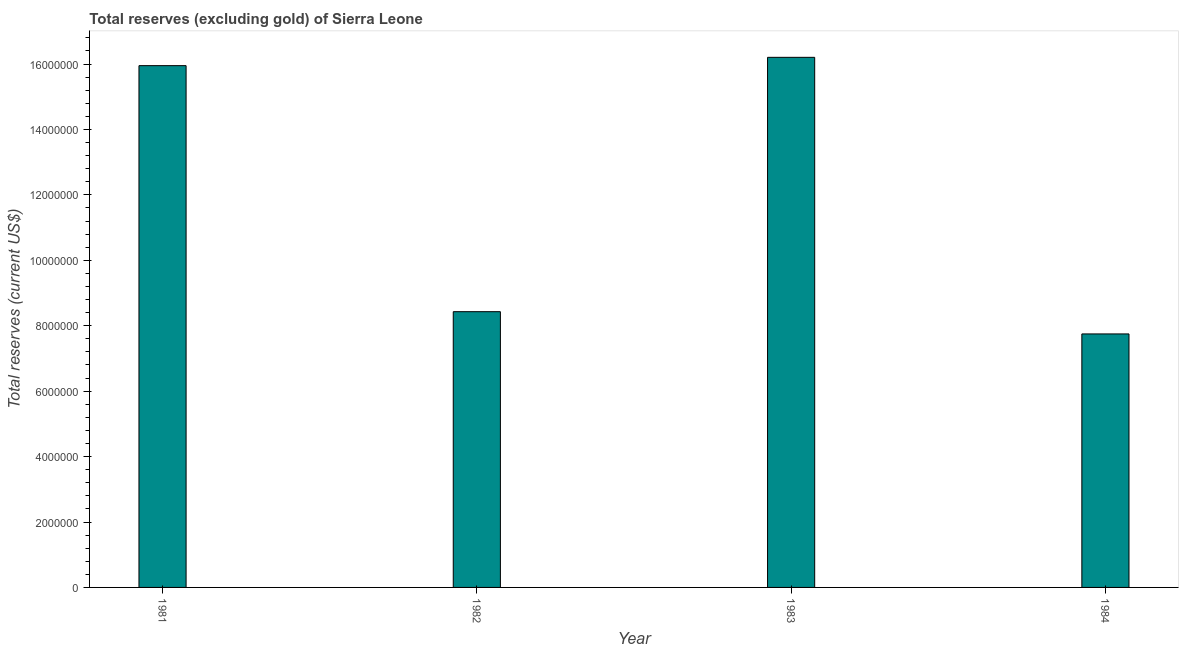Does the graph contain any zero values?
Give a very brief answer. No. Does the graph contain grids?
Offer a terse response. No. What is the title of the graph?
Your answer should be very brief. Total reserves (excluding gold) of Sierra Leone. What is the label or title of the X-axis?
Ensure brevity in your answer.  Year. What is the label or title of the Y-axis?
Your response must be concise. Total reserves (current US$). What is the total reserves (excluding gold) in 1982?
Offer a terse response. 8.43e+06. Across all years, what is the maximum total reserves (excluding gold)?
Your answer should be very brief. 1.62e+07. Across all years, what is the minimum total reserves (excluding gold)?
Make the answer very short. 7.75e+06. In which year was the total reserves (excluding gold) minimum?
Keep it short and to the point. 1984. What is the sum of the total reserves (excluding gold)?
Offer a very short reply. 4.83e+07. What is the difference between the total reserves (excluding gold) in 1982 and 1984?
Your answer should be compact. 6.80e+05. What is the average total reserves (excluding gold) per year?
Offer a terse response. 1.21e+07. What is the median total reserves (excluding gold)?
Provide a short and direct response. 1.22e+07. What is the ratio of the total reserves (excluding gold) in 1983 to that in 1984?
Provide a short and direct response. 2.09. What is the difference between the highest and the second highest total reserves (excluding gold)?
Make the answer very short. 2.55e+05. Is the sum of the total reserves (excluding gold) in 1981 and 1982 greater than the maximum total reserves (excluding gold) across all years?
Offer a very short reply. Yes. What is the difference between the highest and the lowest total reserves (excluding gold)?
Your answer should be very brief. 8.46e+06. How many bars are there?
Your answer should be compact. 4. Are all the bars in the graph horizontal?
Provide a succinct answer. No. How many years are there in the graph?
Your answer should be very brief. 4. What is the difference between two consecutive major ticks on the Y-axis?
Give a very brief answer. 2.00e+06. Are the values on the major ticks of Y-axis written in scientific E-notation?
Your response must be concise. No. What is the Total reserves (current US$) in 1981?
Provide a short and direct response. 1.60e+07. What is the Total reserves (current US$) of 1982?
Your response must be concise. 8.43e+06. What is the Total reserves (current US$) in 1983?
Provide a short and direct response. 1.62e+07. What is the Total reserves (current US$) in 1984?
Offer a terse response. 7.75e+06. What is the difference between the Total reserves (current US$) in 1981 and 1982?
Your response must be concise. 7.52e+06. What is the difference between the Total reserves (current US$) in 1981 and 1983?
Your answer should be compact. -2.55e+05. What is the difference between the Total reserves (current US$) in 1981 and 1984?
Keep it short and to the point. 8.20e+06. What is the difference between the Total reserves (current US$) in 1982 and 1983?
Provide a succinct answer. -7.78e+06. What is the difference between the Total reserves (current US$) in 1982 and 1984?
Keep it short and to the point. 6.80e+05. What is the difference between the Total reserves (current US$) in 1983 and 1984?
Your answer should be compact. 8.46e+06. What is the ratio of the Total reserves (current US$) in 1981 to that in 1982?
Ensure brevity in your answer.  1.89. What is the ratio of the Total reserves (current US$) in 1981 to that in 1984?
Your answer should be very brief. 2.06. What is the ratio of the Total reserves (current US$) in 1982 to that in 1983?
Keep it short and to the point. 0.52. What is the ratio of the Total reserves (current US$) in 1982 to that in 1984?
Your answer should be compact. 1.09. What is the ratio of the Total reserves (current US$) in 1983 to that in 1984?
Provide a succinct answer. 2.09. 